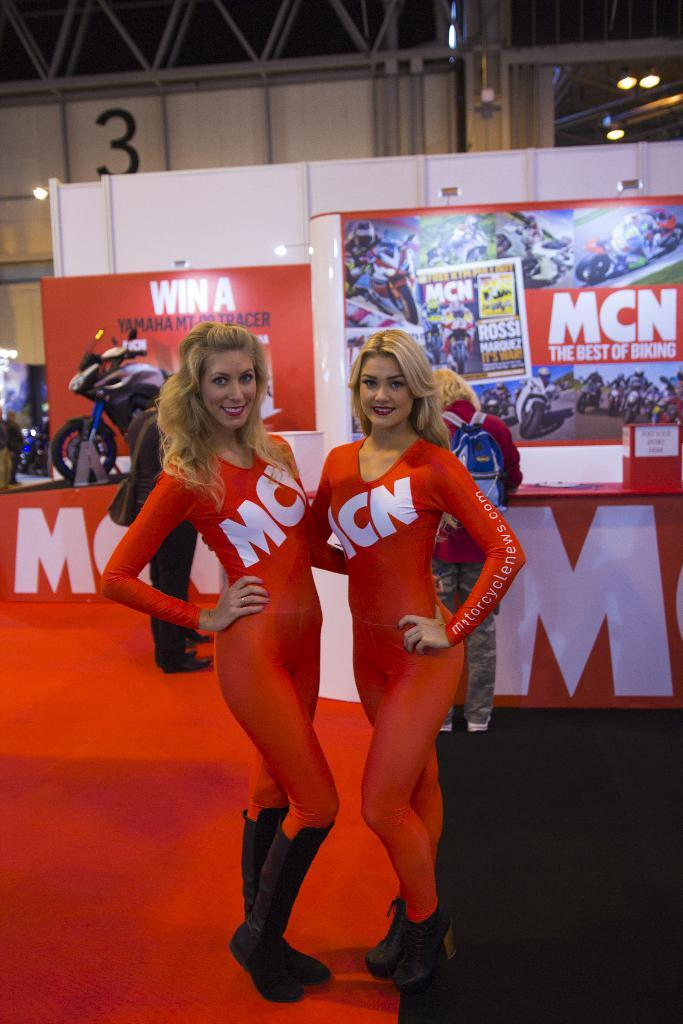<image>
Present a compact description of the photo's key features. MCN is advertised on these two fashion models. 